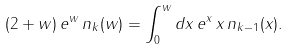Convert formula to latex. <formula><loc_0><loc_0><loc_500><loc_500>( 2 + w ) \, e ^ { w } \, n _ { k } ( w ) = \int _ { 0 } ^ { w } d x \, e ^ { x } \, x \, n _ { k - 1 } ( x ) .</formula> 